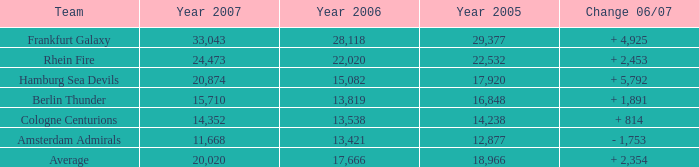What is the sum of Year 2007(s), when the Year 2005 is greater than 29,377? None. 